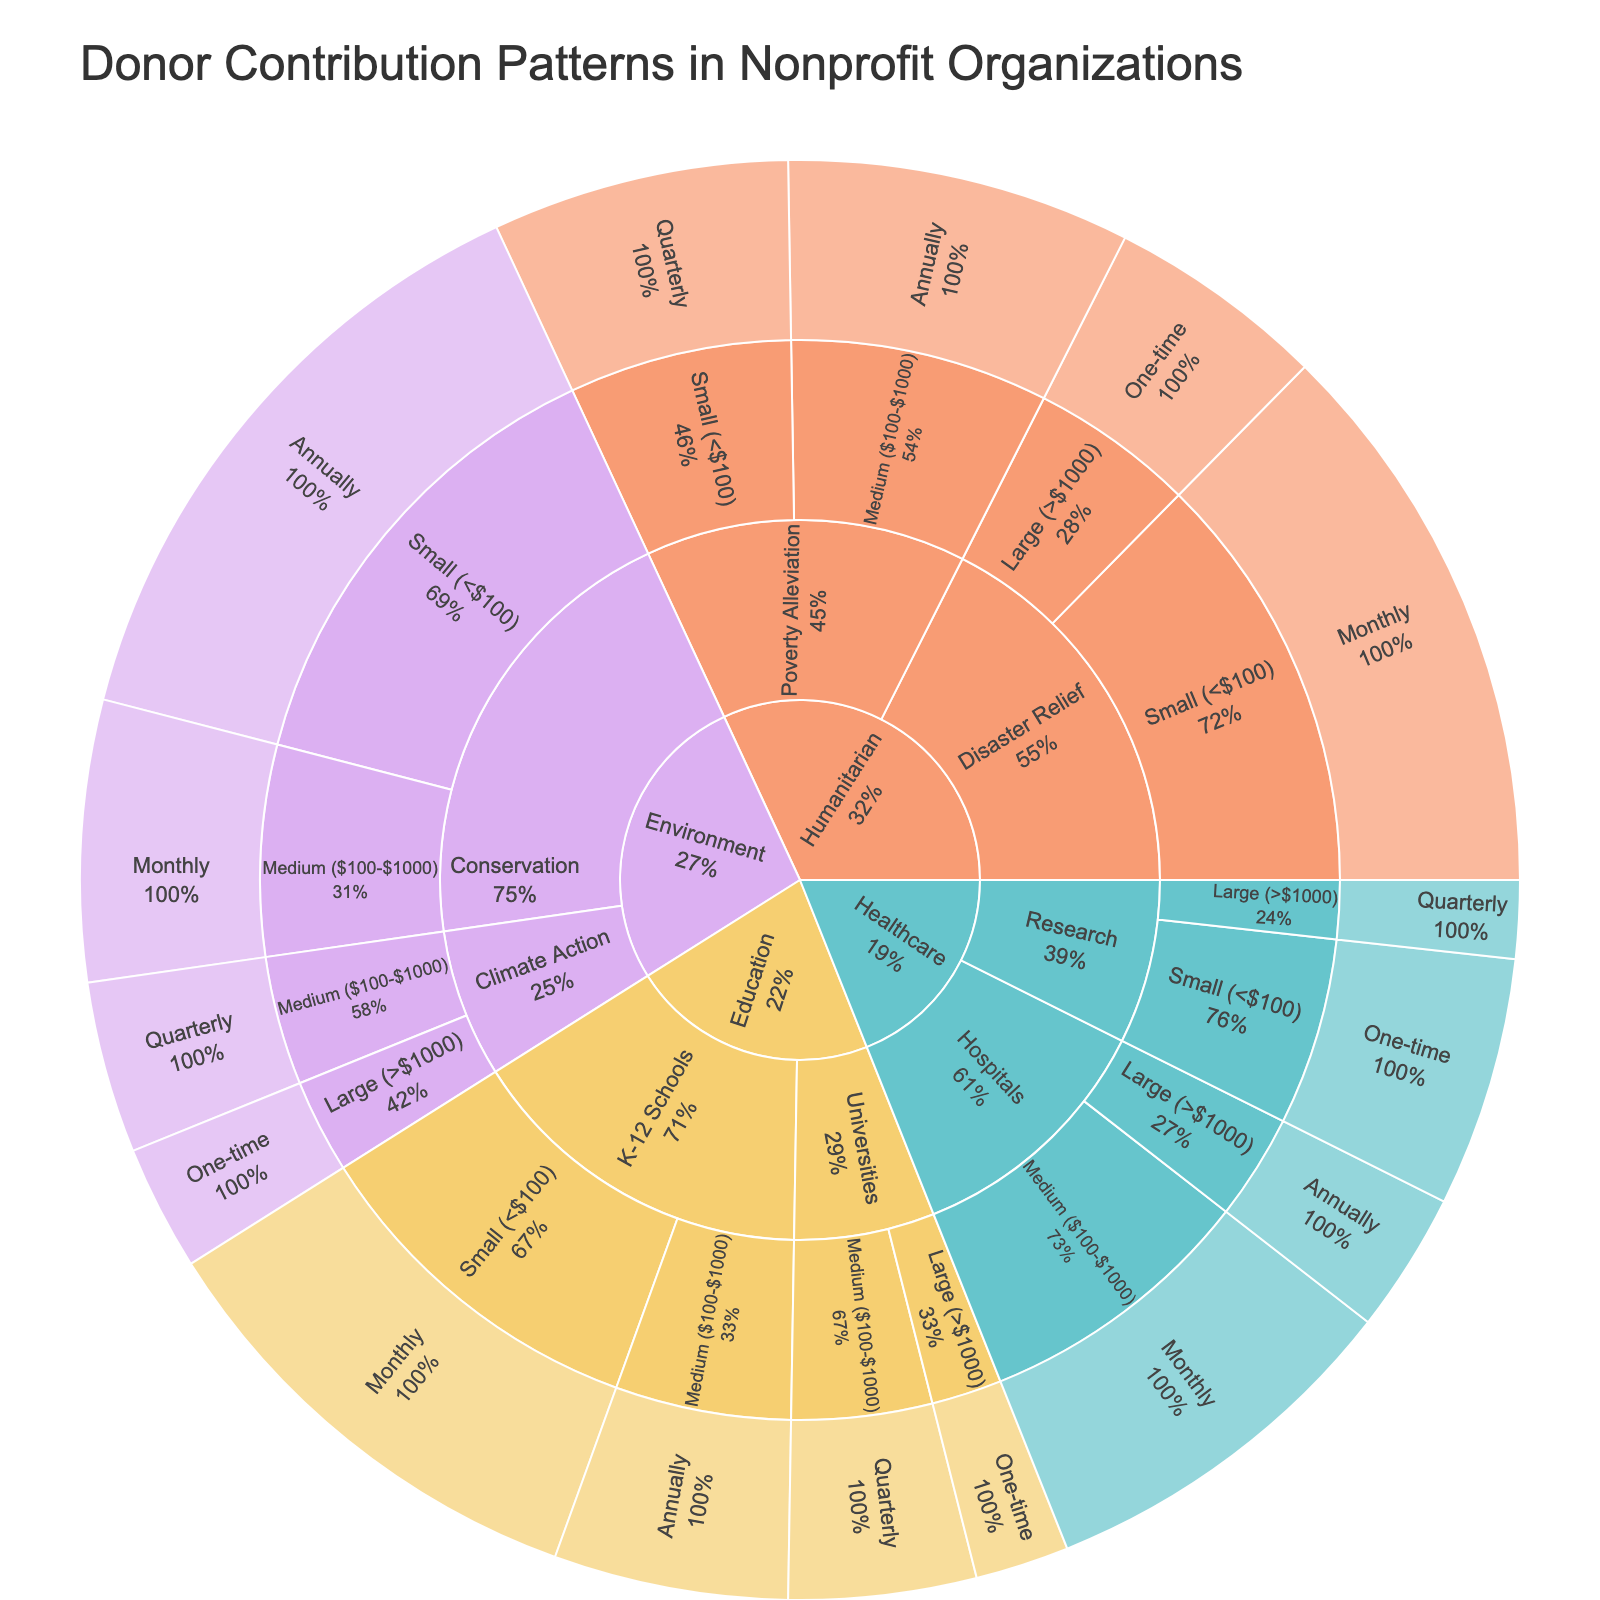What is the title of the sunburst plot? The title is usually located at the top of the plot and clearly states the main subject. In this case, it is "Donor Contribution Patterns in Nonprofit Organizations".
Answer: Donor Contribution Patterns in Nonprofit Organizations Which cause category has the highest proportion of small donations (<$100)? By looking at the visual representation of the sunburst plot, we identify the cause category with the largest segment under the "Small (<$100)" donation amount.
Answer: Humanitarian How many donor contributions fall under the "Medium ($100-$1000)" donation amount for the "Healthcare" cause? In the sunburst plot, navigate to the "Healthcare" cause and then to the "Medium ($100-$1000)" donation amount. Add the counts for all frequencies under this category. Specifically, look at monthly contributions.
Answer: 120 Comparing Education and Healthcare, which cause received more "Large (>$1000)" one-time donations? Identify the segments for "Large (>$1000)" one-time donations under both "Education" and "Healthcare" causes. Compare the values visually.
Answer: Humanitarian What is the total number of monthly contributions across all causes? Sum the "value" counts for each segment identified as "Monthly" frequency across all causes. This includes Education (150), Healthcare (120), and Humanitarian (180).
Answer: 450 Which specific category in the Education cause has the highest value of quarterly contributions? Navigate through the Education cause and find the category under quarterly contributions with the highest value by comparing the values visually.
Answer: Universities What percentage of Environmental donations are "Annually" and "Small (<$100)"? Locate the segment under the Environmental cause for "Annually" and "Small (<$100)" donations, then calculate the proportion by dividing its value by the total Environmental donations and converting it to a percentage. The total for the Environmental cause is the sum of its sub-segments (90 + 200 + 40 + 55).
Answer: 66.67% Between "K-12 Schools" and "Universities" under the Education cause, which has the higher total number of contributions across all amounts and frequencies? Sum the values for each sub-segment under both "K-12 Schools" and "Universities" and compare the totals.
Answer: K-12 Schools How many contributions are categorized as "Quarterly" across all causes and categories? Sum the values of all segments identified with the "Quarterly" frequency across the entire sunburst plot. This includes Universities (60), Climate Action (55), Research (25), and Poverty Alleviation (95).
Answer: 235 